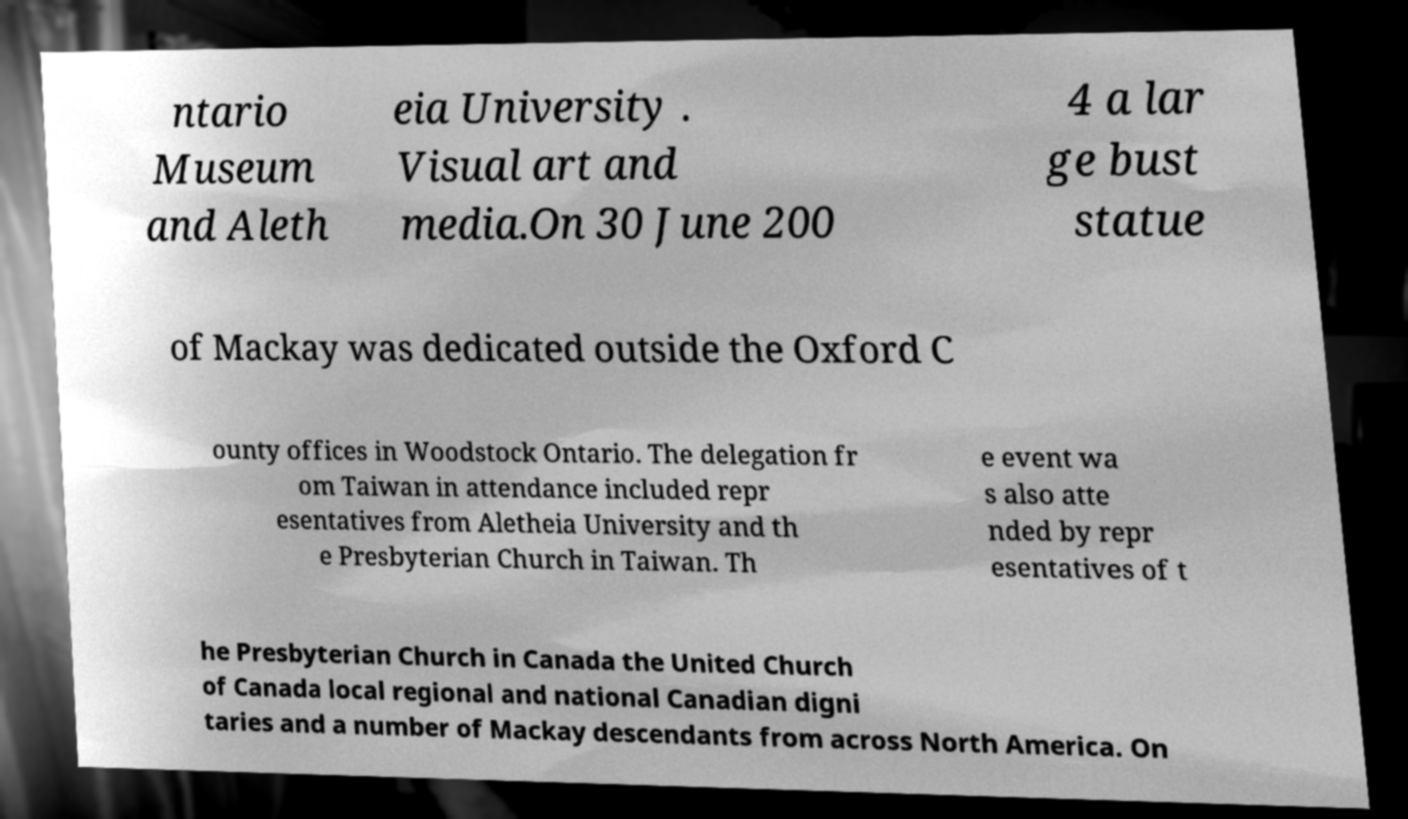What messages or text are displayed in this image? I need them in a readable, typed format. ntario Museum and Aleth eia University . Visual art and media.On 30 June 200 4 a lar ge bust statue of Mackay was dedicated outside the Oxford C ounty offices in Woodstock Ontario. The delegation fr om Taiwan in attendance included repr esentatives from Aletheia University and th e Presbyterian Church in Taiwan. Th e event wa s also atte nded by repr esentatives of t he Presbyterian Church in Canada the United Church of Canada local regional and national Canadian digni taries and a number of Mackay descendants from across North America. On 